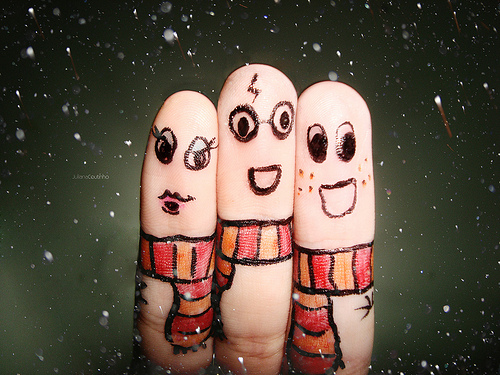<image>
Is the finger behind the finger? No. The finger is not behind the finger. From this viewpoint, the finger appears to be positioned elsewhere in the scene. Where is the scarf in relation to the finger? Is it on the finger? Yes. Looking at the image, I can see the scarf is positioned on top of the finger, with the finger providing support. Is there a ink on the skin? Yes. Looking at the image, I can see the ink is positioned on top of the skin, with the skin providing support. 